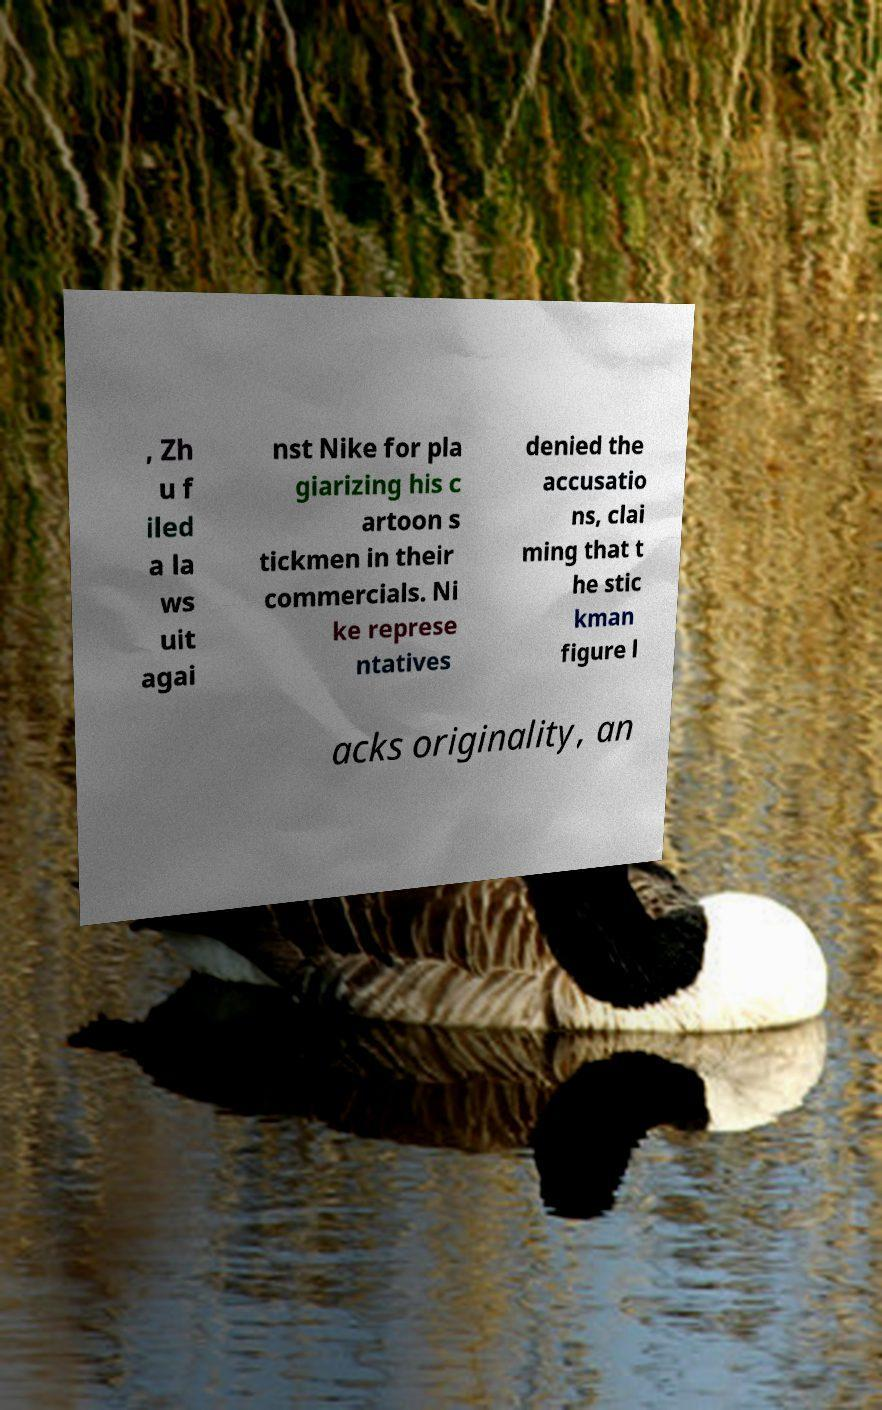Can you read and provide the text displayed in the image?This photo seems to have some interesting text. Can you extract and type it out for me? , Zh u f iled a la ws uit agai nst Nike for pla giarizing his c artoon s tickmen in their commercials. Ni ke represe ntatives denied the accusatio ns, clai ming that t he stic kman figure l acks originality, an 